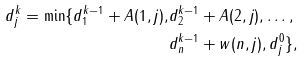Convert formula to latex. <formula><loc_0><loc_0><loc_500><loc_500>d _ { j } ^ { k } = \min \{ d _ { 1 } ^ { k - 1 } + A ( 1 , j ) , & d _ { 2 } ^ { k - 1 } + A ( 2 , j ) , \dots , \\ & d _ { n } ^ { k - 1 } + w ( n , j ) , d _ { j } ^ { 0 } \} ,</formula> 